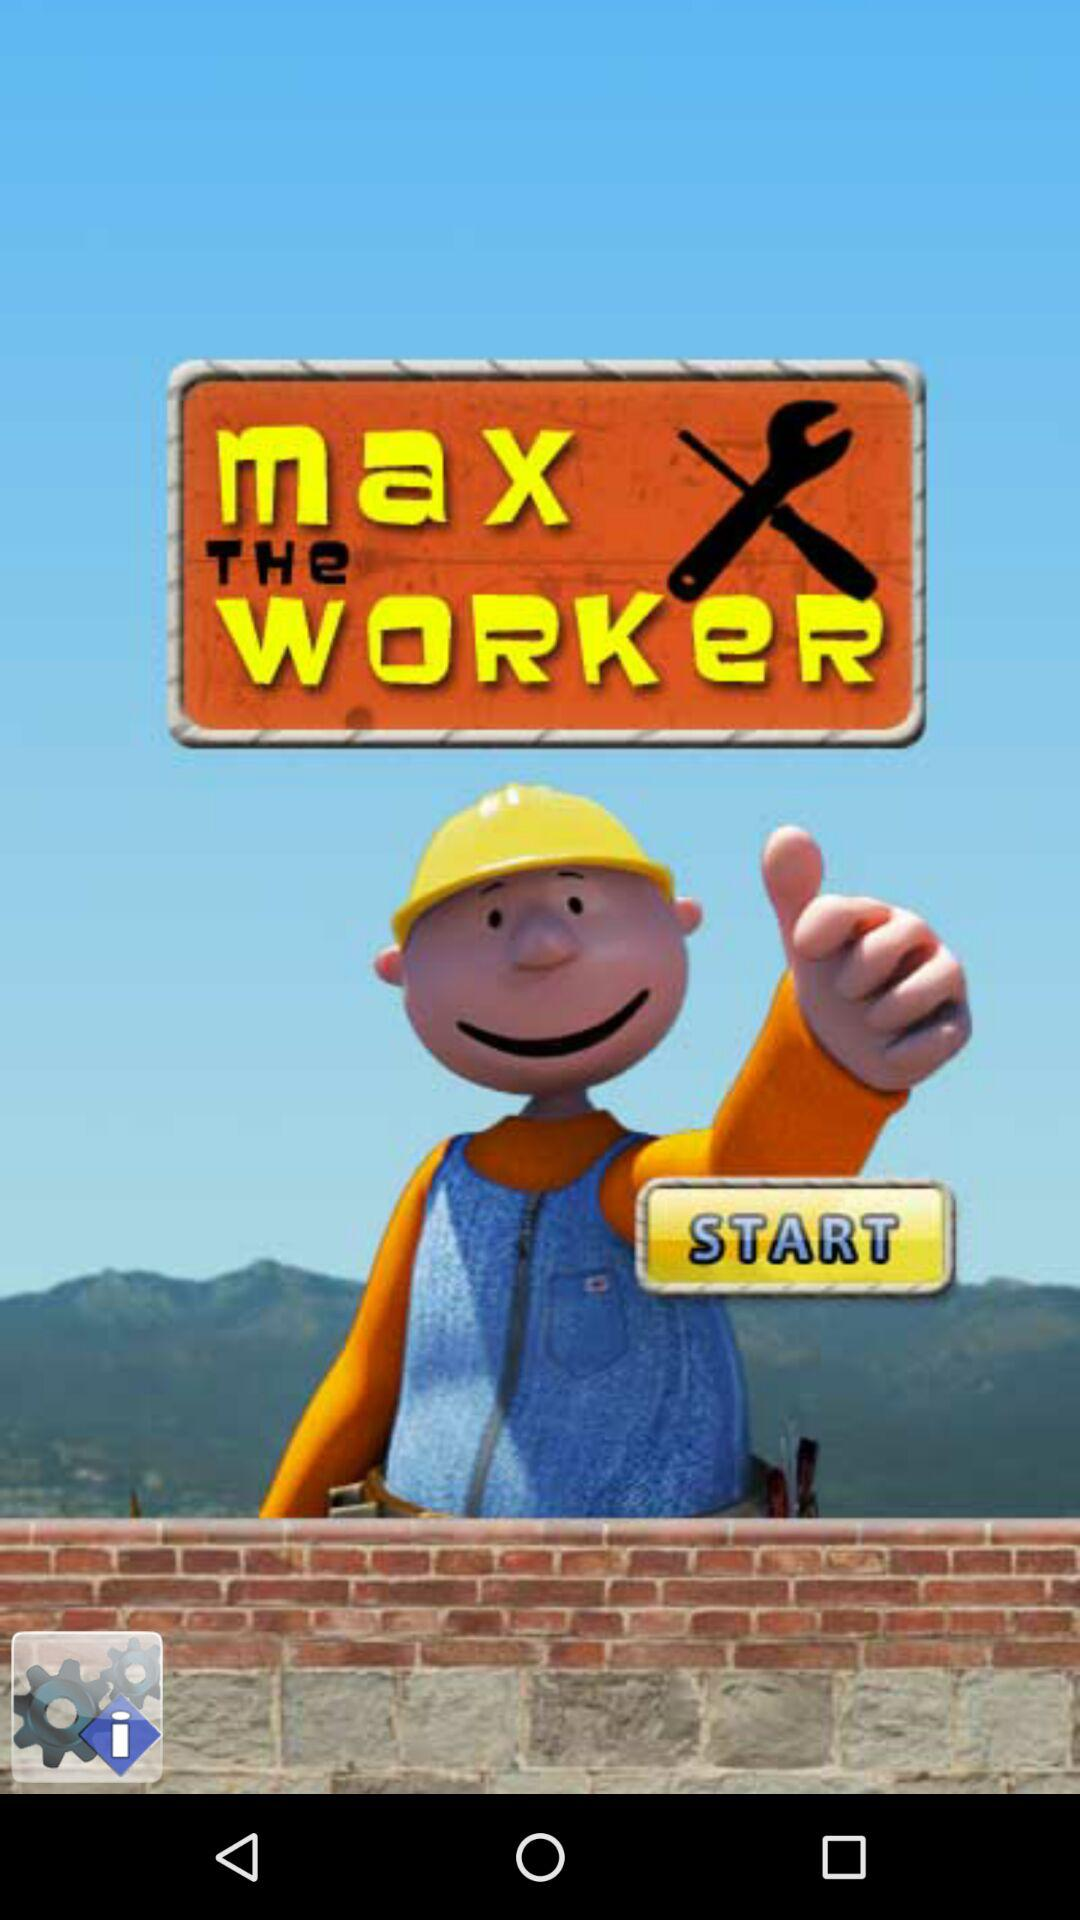What version of the application is being used?
When the provided information is insufficient, respond with <no answer>. <no answer> 